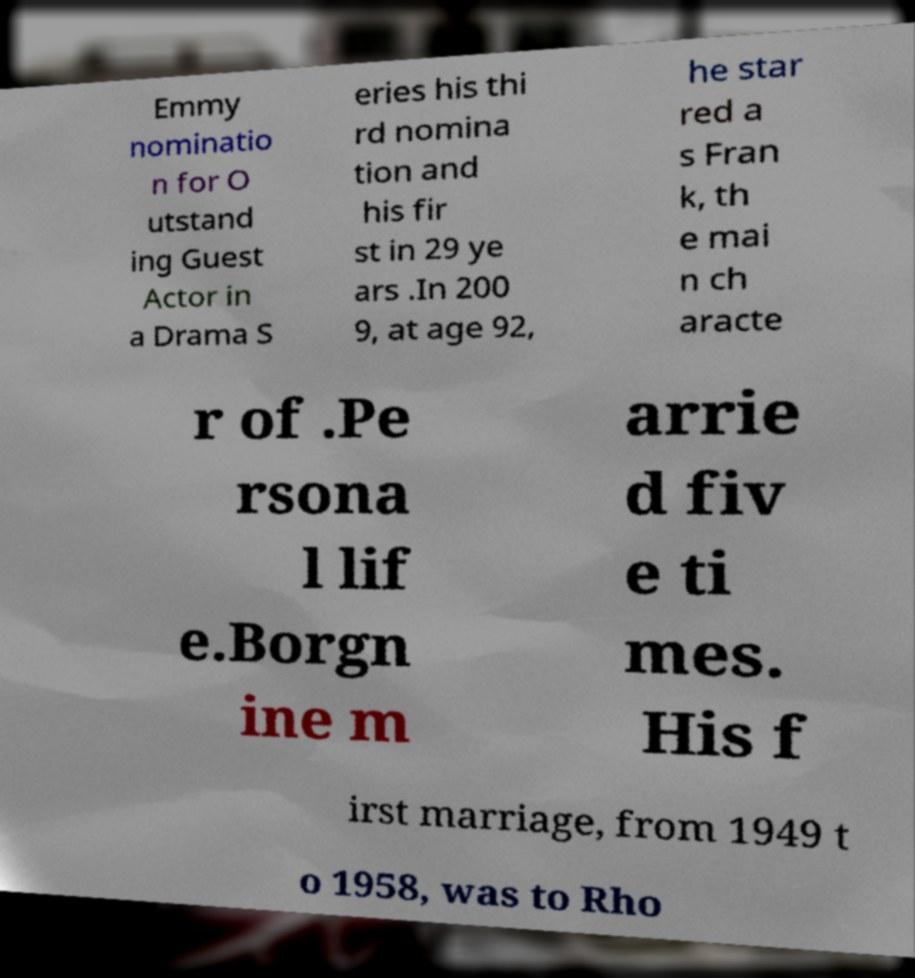There's text embedded in this image that I need extracted. Can you transcribe it verbatim? Emmy nominatio n for O utstand ing Guest Actor in a Drama S eries his thi rd nomina tion and his fir st in 29 ye ars .In 200 9, at age 92, he star red a s Fran k, th e mai n ch aracte r of .Pe rsona l lif e.Borgn ine m arrie d fiv e ti mes. His f irst marriage, from 1949 t o 1958, was to Rho 